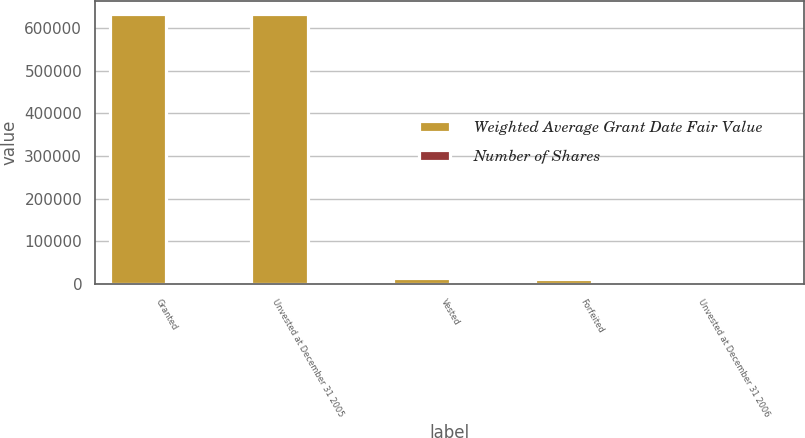<chart> <loc_0><loc_0><loc_500><loc_500><stacked_bar_chart><ecel><fcel>Granted<fcel>Unvested at December 31 2005<fcel>Vested<fcel>Forfeited<fcel>Unvested at December 31 2006<nl><fcel>Weighted Average Grant Date Fair Value<fcel>633200<fcel>633200<fcel>13119<fcel>11060<fcel>20.68<nl><fcel>Number of Shares<fcel>18.89<fcel>18.89<fcel>19.62<fcel>19.55<fcel>20.68<nl></chart> 